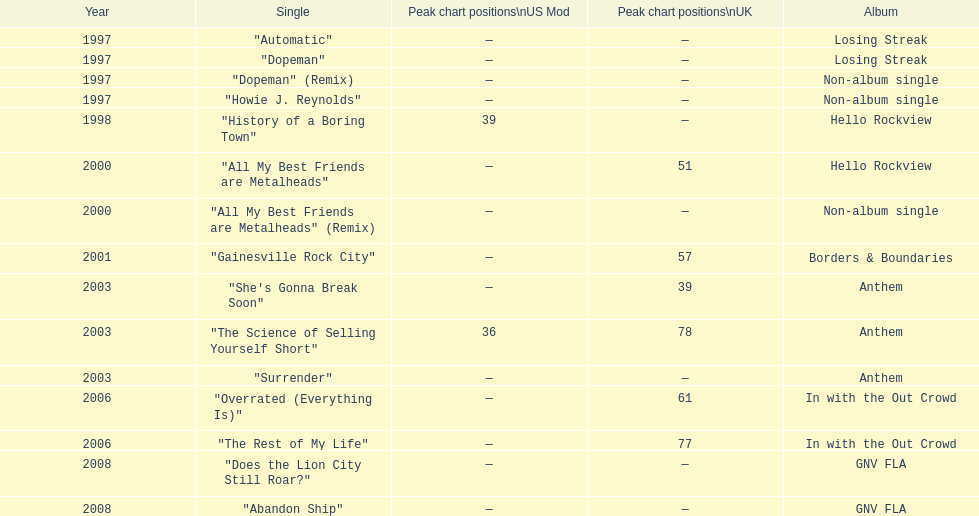Which album had the single automatic? Losing Streak. 